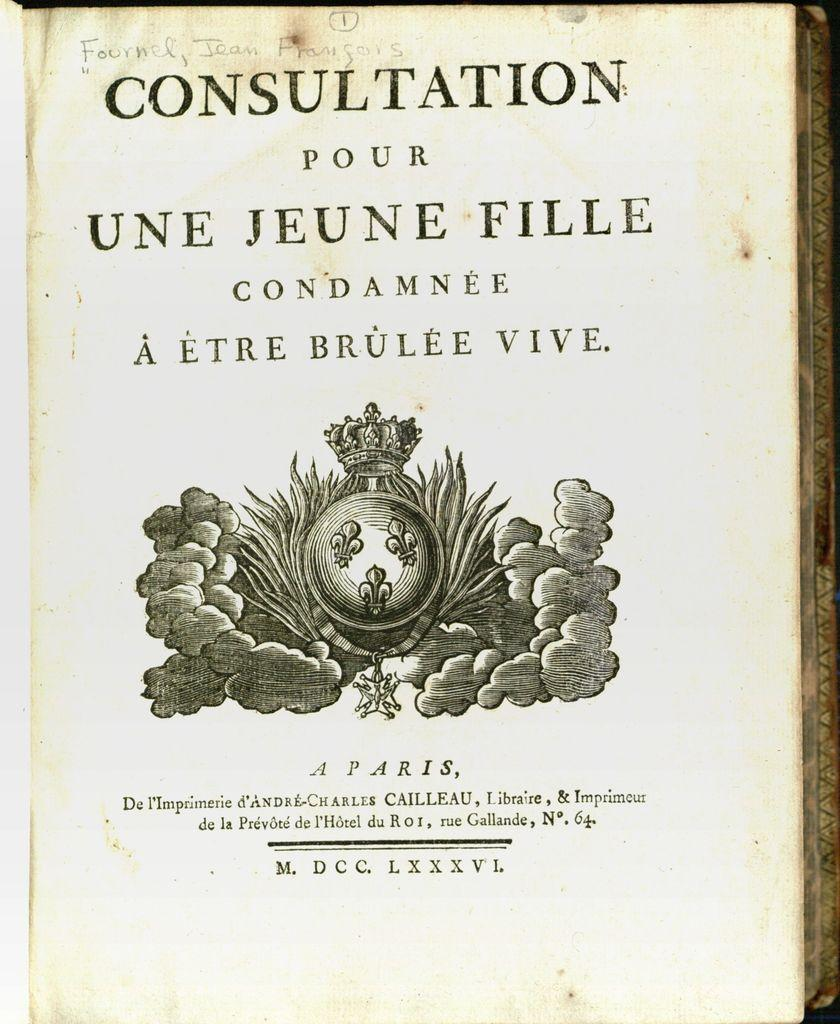<image>
Describe the image concisely. A copy of Consultation Pour Une Jeune Fille Condamnée À Étre Brùlée Vive. 